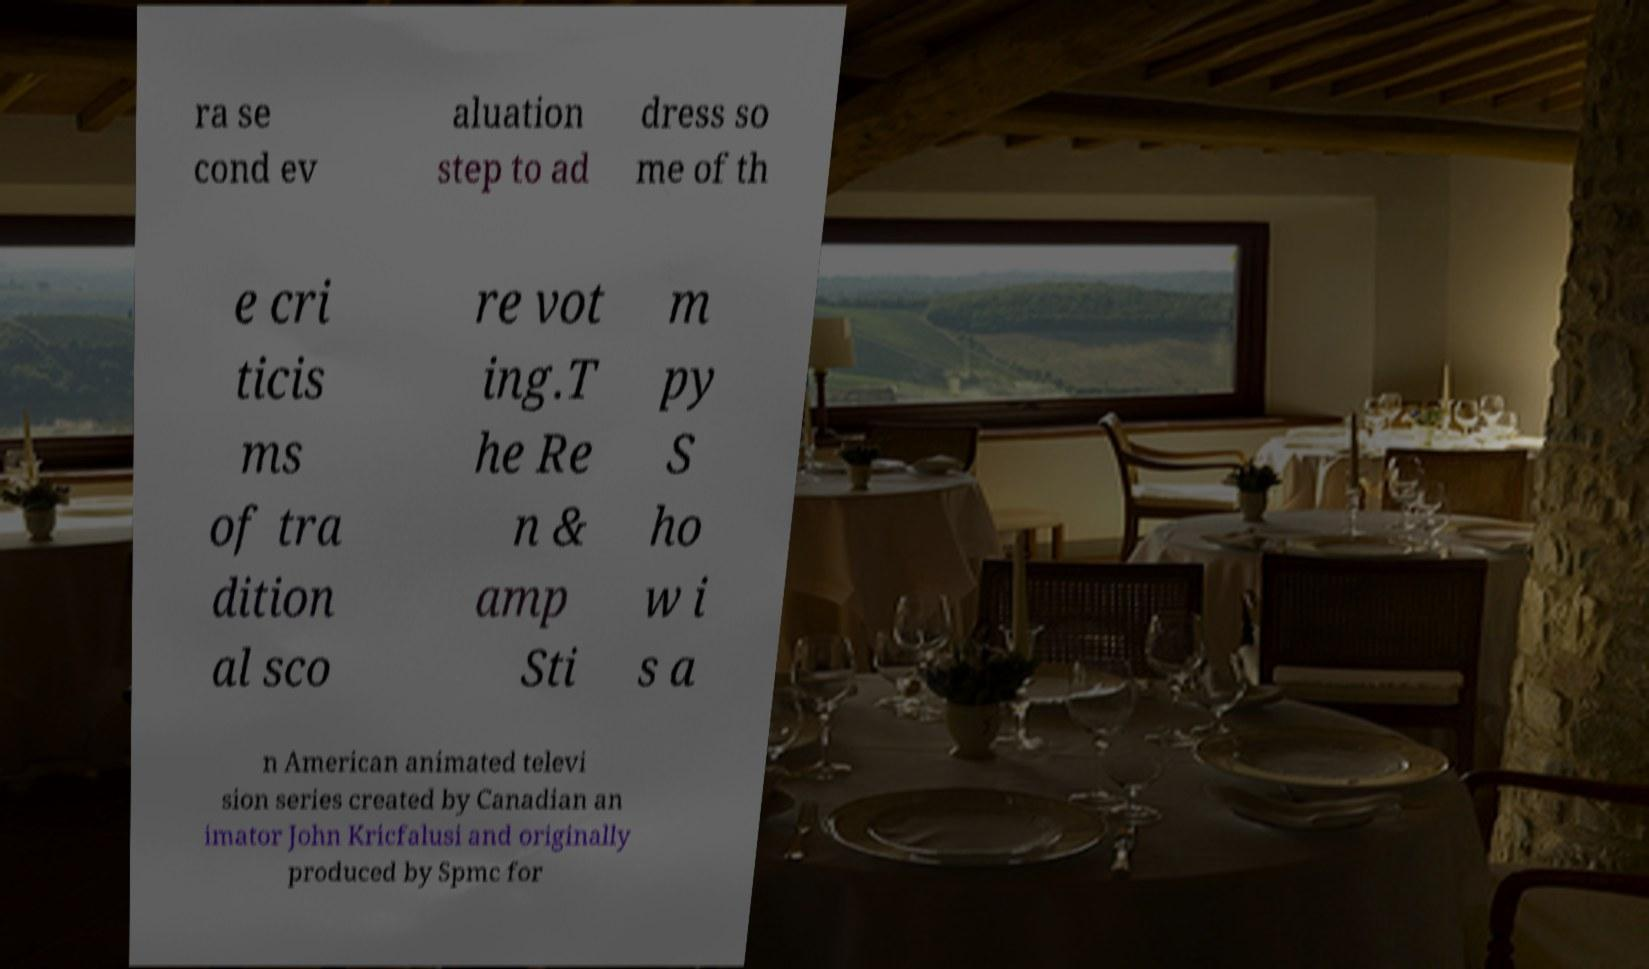Could you extract and type out the text from this image? ra se cond ev aluation step to ad dress so me of th e cri ticis ms of tra dition al sco re vot ing.T he Re n & amp Sti m py S ho w i s a n American animated televi sion series created by Canadian an imator John Kricfalusi and originally produced by Spmc for 